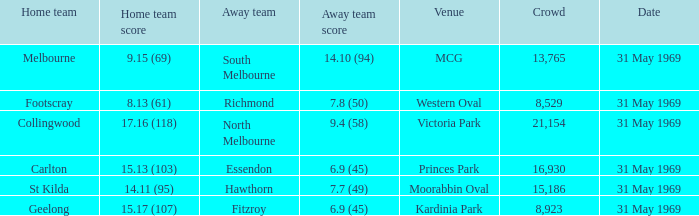11 (95)? St Kilda. 